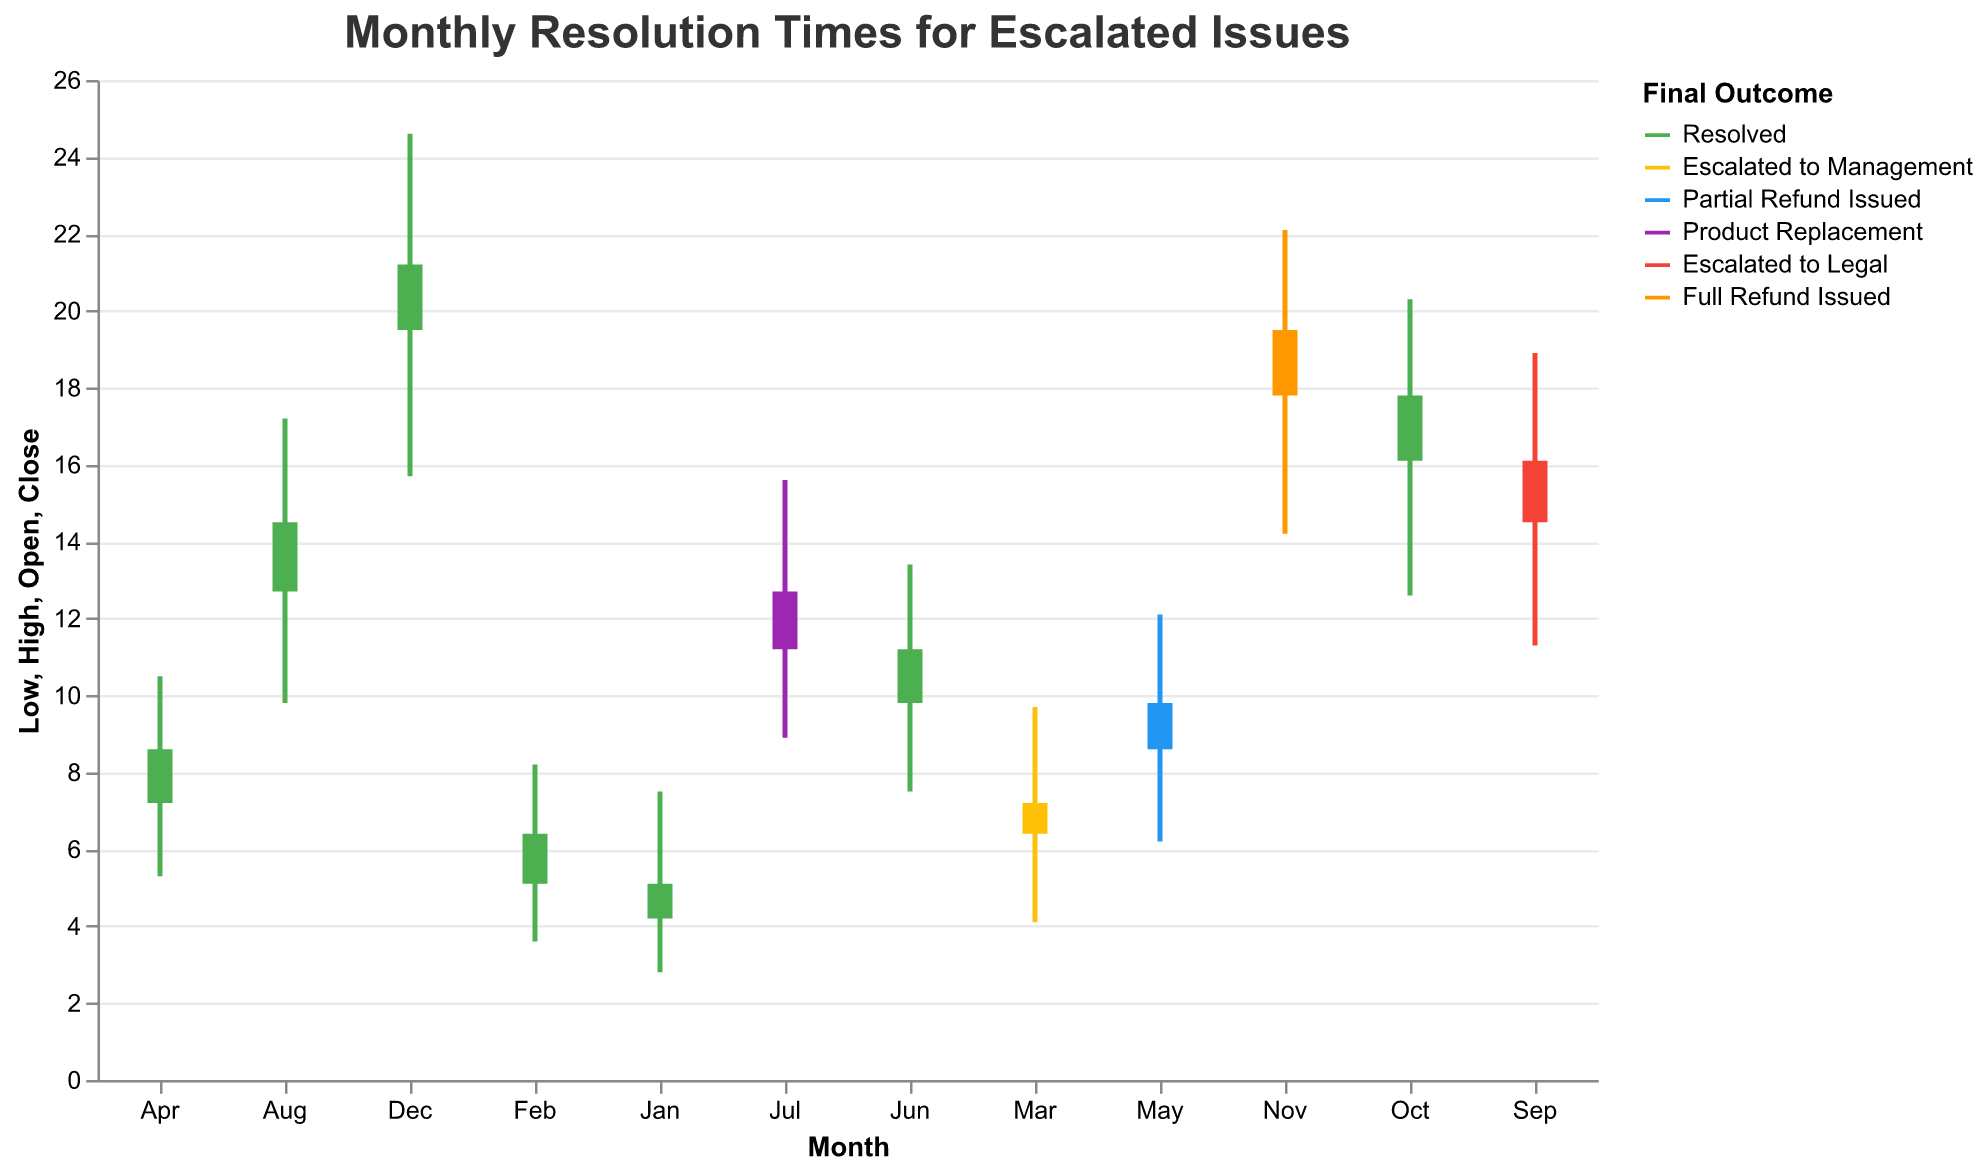What is the title of the chart? The title of the chart is displayed at the top and reads "Monthly Resolution Times for Escalated Issues."
Answer: Monthly Resolution Times for Escalated Issues What is the resolution outcome for March? Looking at the color legend and matching the bar color for March, the final outcome is "Escalated to Management."
Answer: Escalated to Management Which month had the highest 'Close' value and what was it? The 'Close' value is represented by the upper boundary of the bar's color. In December, the 'Close' value reaches 21.2, which is the highest among all months.
Answer: December, 21.2 How many months saw the final resolution as "Resolved"? By looking at the color legend and matching "Resolved" to the green bars, we can count the months that had this final outcome (January, February, April, June, August, October, December). There are 7 months in total.
Answer: 7 Which month had the greatest range between 'High' and 'Low'? The range is the difference between the 'High' and 'Low' values. November has the range computed as 22.1 - 14.2 = 7.9, which is the greatest across all months.
Answer: November In which month were issues still 'Open' at the highest rate at the beginning of the month? By comparing the 'Open' values for each month, December has the highest 'Open' value at 19.5.
Answer: December Which months had the outcome "Partial Refund Issued" or "Full Refund Issued"? Looking at the colors and matching "Partial Refund Issued" (blue) with May and "Full Refund Issued" (orange) with November, these are the months.
Answer: May, November Between January and June, which month had the lowest 'Low' value? Checking the 'Low' values between January and June, January had the lowest 'Low' value at 2.8.
Answer: January What's the average 'Close' value for the months where the outcome was "Resolved"? Summing the 'Close' values for 'Resolved' months (January 5.1 + February 6.4 + April 8.6 + June 11.2 + August 14.5 + October 17.8 + December 21.2) and dividing by the number of these months (7), the average is (84.8 / 7) = 12.1.
Answer: 12.1 Which month required intervention in Legal or Management departments, and what does this imply? March and September had outcomes "Escalated to Management" and "Escalated to Legal" respectively. This implies the issues were severe enough to need higher-level intervention.
Answer: March and September, severe issues 